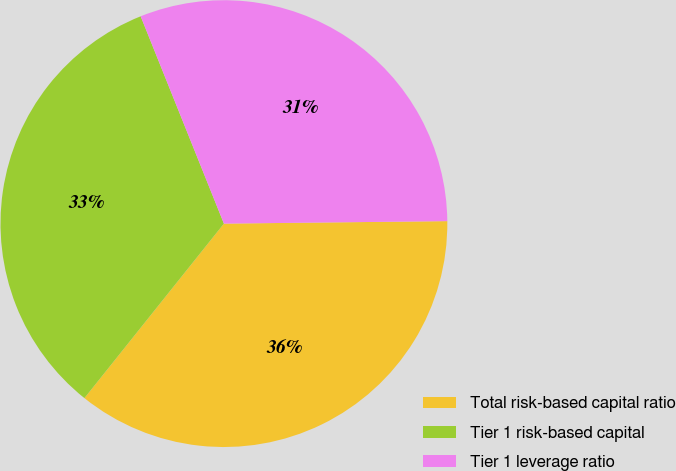Convert chart. <chart><loc_0><loc_0><loc_500><loc_500><pie_chart><fcel>Total risk-based capital ratio<fcel>Tier 1 risk-based capital<fcel>Tier 1 leverage ratio<nl><fcel>35.91%<fcel>33.19%<fcel>30.9%<nl></chart> 